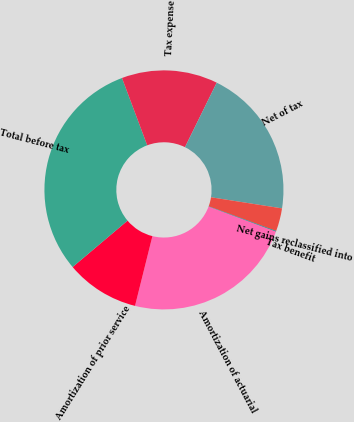Convert chart to OTSL. <chart><loc_0><loc_0><loc_500><loc_500><pie_chart><fcel>Amortization of actuarial<fcel>Amortization of prior service<fcel>Total before tax<fcel>Tax expense<fcel>Net of tax<fcel>Net gains reclassified into<fcel>Tax benefit<nl><fcel>23.23%<fcel>9.95%<fcel>30.45%<fcel>12.99%<fcel>20.19%<fcel>3.11%<fcel>0.08%<nl></chart> 